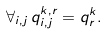Convert formula to latex. <formula><loc_0><loc_0><loc_500><loc_500>\forall _ { i , j } \, q ^ { k , r } _ { i , j } = q ^ { k } _ { r } .</formula> 